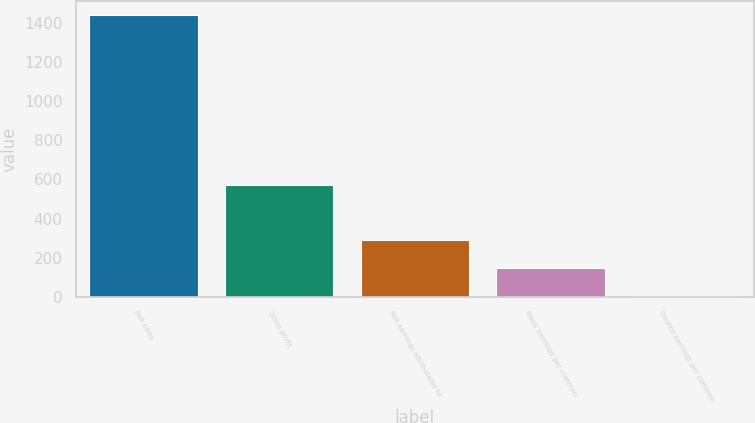<chart> <loc_0><loc_0><loc_500><loc_500><bar_chart><fcel>Net sales<fcel>Gross profit<fcel>Net earnings attributable to<fcel>Basic earnings per common<fcel>Diluted earnings per common<nl><fcel>1440.9<fcel>572.2<fcel>289.42<fcel>145.49<fcel>1.56<nl></chart> 